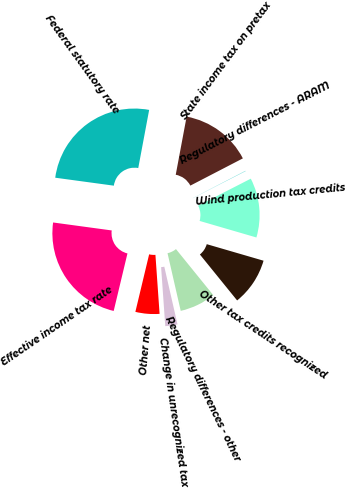Convert chart to OTSL. <chart><loc_0><loc_0><loc_500><loc_500><pie_chart><fcel>Federal statutory rate<fcel>State income tax on pretax<fcel>Regulatory differences - ARAM<fcel>Wind production tax credits<fcel>Other tax credits recognized<fcel>Regulatory differences - other<fcel>Change in unrecognized tax<fcel>Other net<fcel>Effective income tax rate<nl><fcel>25.8%<fcel>14.44%<fcel>0.07%<fcel>12.05%<fcel>9.65%<fcel>7.26%<fcel>2.46%<fcel>4.86%<fcel>23.41%<nl></chart> 